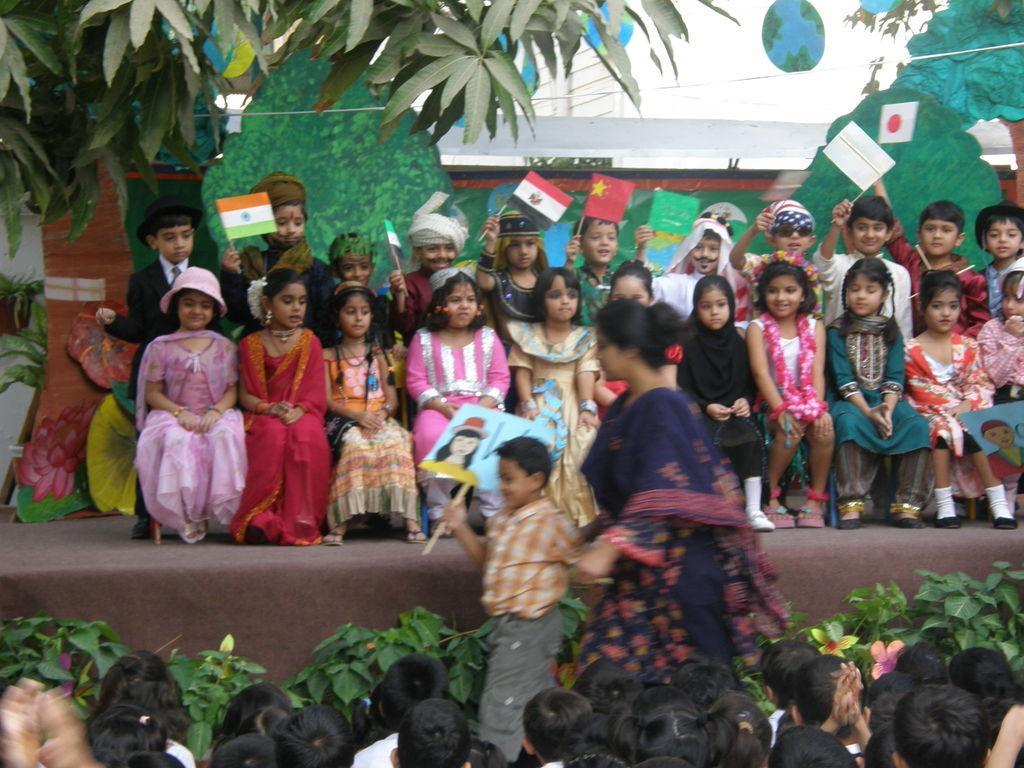Could you give a brief overview of what you see in this image? In this image we can see group of children sitting on a stage. A woman is standing in front of the stage. In the background we can see tree a building,group of plants and sky. 